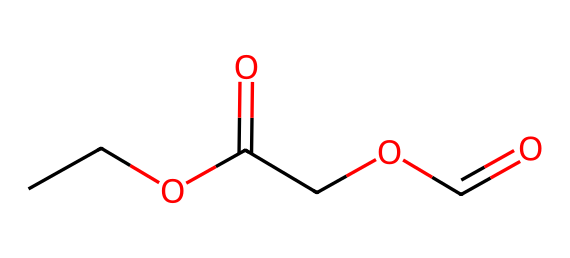What is the functional group present in this molecule? The SMILES representation indicates the presence of carboxylic acid groups, denoted by "C(=O)O". Each occurrence of this grouping in the structure identifies the functional group.
Answer: carboxylic acid How many carbon atoms are in the molecule? Analyzing the SMILES string, we count each carbon (C) listed. The structure includes a total of 6 carbon atoms shown in the representation.
Answer: 6 What is the total number of oxygen atoms in the structure? The representation contains "O" twice within the carboxylic acid groups. By counting all "O" in the molecule, we find there are a total of 4 oxygen atoms.
Answer: 4 Which type of polymer does this structure resemble? The combination of carboxylic acid groups and carbon backbones suggests that this chemical is similar to polyester, commonly found in synthetic fabrics.
Answer: polyester Is this molecule likely to be hydrophobic or hydrophilic? The presence of polar carboxylic acid groups suggests that the molecule is hydrophilic because these groups can interact with water.
Answer: hydrophilic What is the degree of saturation of this compound? The molecule contains no double bonds or rings except for the carbonyls in the carboxylic acid. Given this structure, it is fully saturated in terms of carbon connectivity in the context of carbon chains.
Answer: saturated 